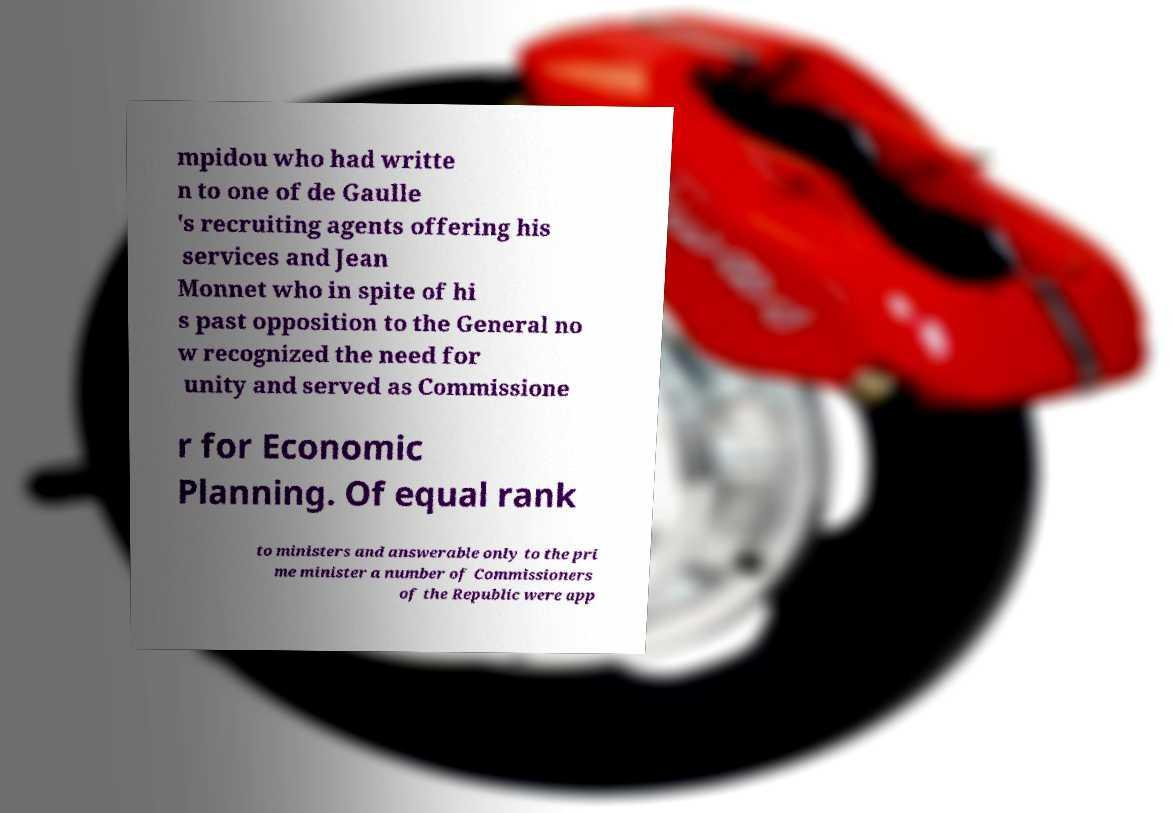Can you accurately transcribe the text from the provided image for me? mpidou who had writte n to one of de Gaulle 's recruiting agents offering his services and Jean Monnet who in spite of hi s past opposition to the General no w recognized the need for unity and served as Commissione r for Economic Planning. Of equal rank to ministers and answerable only to the pri me minister a number of Commissioners of the Republic were app 